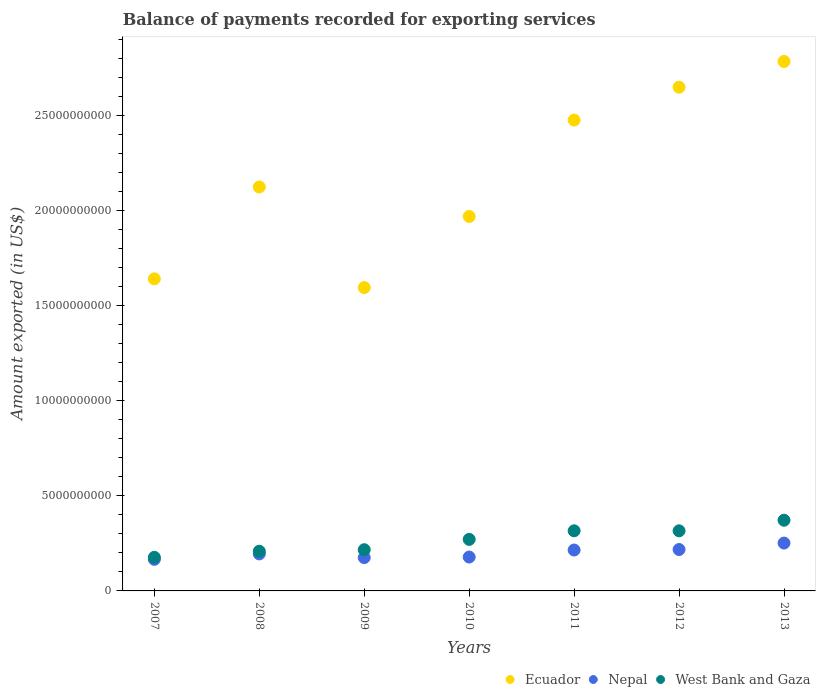Is the number of dotlines equal to the number of legend labels?
Ensure brevity in your answer.  Yes. What is the amount exported in Ecuador in 2011?
Give a very brief answer. 2.48e+1. Across all years, what is the maximum amount exported in Nepal?
Offer a very short reply. 2.52e+09. Across all years, what is the minimum amount exported in Nepal?
Give a very brief answer. 1.66e+09. In which year was the amount exported in Ecuador minimum?
Keep it short and to the point. 2009. What is the total amount exported in Ecuador in the graph?
Provide a short and direct response. 1.52e+11. What is the difference between the amount exported in Nepal in 2010 and that in 2013?
Offer a terse response. -7.35e+08. What is the difference between the amount exported in Ecuador in 2011 and the amount exported in Nepal in 2013?
Keep it short and to the point. 2.22e+1. What is the average amount exported in Nepal per year?
Your answer should be compact. 2.00e+09. In the year 2012, what is the difference between the amount exported in Ecuador and amount exported in Nepal?
Your response must be concise. 2.43e+1. In how many years, is the amount exported in West Bank and Gaza greater than 19000000000 US$?
Make the answer very short. 0. What is the ratio of the amount exported in Ecuador in 2009 to that in 2010?
Your answer should be compact. 0.81. What is the difference between the highest and the second highest amount exported in Ecuador?
Your answer should be very brief. 1.35e+09. What is the difference between the highest and the lowest amount exported in Nepal?
Keep it short and to the point. 8.55e+08. In how many years, is the amount exported in Ecuador greater than the average amount exported in Ecuador taken over all years?
Make the answer very short. 3. Does the amount exported in Nepal monotonically increase over the years?
Give a very brief answer. No. Is the amount exported in West Bank and Gaza strictly greater than the amount exported in Nepal over the years?
Your response must be concise. Yes. How many dotlines are there?
Provide a short and direct response. 3. How many years are there in the graph?
Keep it short and to the point. 7. What is the difference between two consecutive major ticks on the Y-axis?
Offer a very short reply. 5.00e+09. How many legend labels are there?
Provide a succinct answer. 3. What is the title of the graph?
Provide a short and direct response. Balance of payments recorded for exporting services. Does "United Kingdom" appear as one of the legend labels in the graph?
Provide a succinct answer. No. What is the label or title of the X-axis?
Provide a succinct answer. Years. What is the label or title of the Y-axis?
Provide a succinct answer. Amount exported (in US$). What is the Amount exported (in US$) in Ecuador in 2007?
Your answer should be compact. 1.64e+1. What is the Amount exported (in US$) in Nepal in 2007?
Your answer should be compact. 1.66e+09. What is the Amount exported (in US$) of West Bank and Gaza in 2007?
Keep it short and to the point. 1.77e+09. What is the Amount exported (in US$) of Ecuador in 2008?
Your response must be concise. 2.12e+1. What is the Amount exported (in US$) of Nepal in 2008?
Your answer should be very brief. 1.95e+09. What is the Amount exported (in US$) of West Bank and Gaza in 2008?
Your answer should be very brief. 2.09e+09. What is the Amount exported (in US$) in Ecuador in 2009?
Make the answer very short. 1.59e+1. What is the Amount exported (in US$) in Nepal in 2009?
Offer a very short reply. 1.75e+09. What is the Amount exported (in US$) in West Bank and Gaza in 2009?
Provide a short and direct response. 2.17e+09. What is the Amount exported (in US$) of Ecuador in 2010?
Provide a short and direct response. 1.97e+1. What is the Amount exported (in US$) of Nepal in 2010?
Give a very brief answer. 1.78e+09. What is the Amount exported (in US$) of West Bank and Gaza in 2010?
Make the answer very short. 2.71e+09. What is the Amount exported (in US$) of Ecuador in 2011?
Provide a succinct answer. 2.48e+1. What is the Amount exported (in US$) of Nepal in 2011?
Ensure brevity in your answer.  2.15e+09. What is the Amount exported (in US$) in West Bank and Gaza in 2011?
Ensure brevity in your answer.  3.16e+09. What is the Amount exported (in US$) in Ecuador in 2012?
Keep it short and to the point. 2.65e+1. What is the Amount exported (in US$) in Nepal in 2012?
Provide a short and direct response. 2.18e+09. What is the Amount exported (in US$) of West Bank and Gaza in 2012?
Offer a very short reply. 3.16e+09. What is the Amount exported (in US$) of Ecuador in 2013?
Keep it short and to the point. 2.78e+1. What is the Amount exported (in US$) in Nepal in 2013?
Give a very brief answer. 2.52e+09. What is the Amount exported (in US$) in West Bank and Gaza in 2013?
Your answer should be compact. 3.72e+09. Across all years, what is the maximum Amount exported (in US$) of Ecuador?
Keep it short and to the point. 2.78e+1. Across all years, what is the maximum Amount exported (in US$) of Nepal?
Provide a succinct answer. 2.52e+09. Across all years, what is the maximum Amount exported (in US$) in West Bank and Gaza?
Ensure brevity in your answer.  3.72e+09. Across all years, what is the minimum Amount exported (in US$) of Ecuador?
Ensure brevity in your answer.  1.59e+1. Across all years, what is the minimum Amount exported (in US$) in Nepal?
Provide a succinct answer. 1.66e+09. Across all years, what is the minimum Amount exported (in US$) of West Bank and Gaza?
Ensure brevity in your answer.  1.77e+09. What is the total Amount exported (in US$) of Ecuador in the graph?
Your response must be concise. 1.52e+11. What is the total Amount exported (in US$) in Nepal in the graph?
Provide a short and direct response. 1.40e+1. What is the total Amount exported (in US$) in West Bank and Gaza in the graph?
Make the answer very short. 1.88e+1. What is the difference between the Amount exported (in US$) in Ecuador in 2007 and that in 2008?
Provide a short and direct response. -4.83e+09. What is the difference between the Amount exported (in US$) in Nepal in 2007 and that in 2008?
Offer a terse response. -2.85e+08. What is the difference between the Amount exported (in US$) of West Bank and Gaza in 2007 and that in 2008?
Offer a very short reply. -3.21e+08. What is the difference between the Amount exported (in US$) in Ecuador in 2007 and that in 2009?
Provide a short and direct response. 4.60e+08. What is the difference between the Amount exported (in US$) in Nepal in 2007 and that in 2009?
Provide a short and direct response. -9.15e+07. What is the difference between the Amount exported (in US$) of West Bank and Gaza in 2007 and that in 2009?
Make the answer very short. -4.00e+08. What is the difference between the Amount exported (in US$) of Ecuador in 2007 and that in 2010?
Provide a succinct answer. -3.28e+09. What is the difference between the Amount exported (in US$) in Nepal in 2007 and that in 2010?
Make the answer very short. -1.21e+08. What is the difference between the Amount exported (in US$) in West Bank and Gaza in 2007 and that in 2010?
Your response must be concise. -9.44e+08. What is the difference between the Amount exported (in US$) in Ecuador in 2007 and that in 2011?
Your answer should be very brief. -8.35e+09. What is the difference between the Amount exported (in US$) in Nepal in 2007 and that in 2011?
Provide a short and direct response. -4.90e+08. What is the difference between the Amount exported (in US$) of West Bank and Gaza in 2007 and that in 2011?
Give a very brief answer. -1.39e+09. What is the difference between the Amount exported (in US$) in Ecuador in 2007 and that in 2012?
Give a very brief answer. -1.01e+1. What is the difference between the Amount exported (in US$) in Nepal in 2007 and that in 2012?
Offer a terse response. -5.16e+08. What is the difference between the Amount exported (in US$) in West Bank and Gaza in 2007 and that in 2012?
Your response must be concise. -1.39e+09. What is the difference between the Amount exported (in US$) of Ecuador in 2007 and that in 2013?
Keep it short and to the point. -1.14e+1. What is the difference between the Amount exported (in US$) in Nepal in 2007 and that in 2013?
Provide a short and direct response. -8.55e+08. What is the difference between the Amount exported (in US$) in West Bank and Gaza in 2007 and that in 2013?
Provide a short and direct response. -1.95e+09. What is the difference between the Amount exported (in US$) in Ecuador in 2008 and that in 2009?
Your response must be concise. 5.29e+09. What is the difference between the Amount exported (in US$) in Nepal in 2008 and that in 2009?
Your answer should be compact. 1.94e+08. What is the difference between the Amount exported (in US$) of West Bank and Gaza in 2008 and that in 2009?
Provide a succinct answer. -7.94e+07. What is the difference between the Amount exported (in US$) in Ecuador in 2008 and that in 2010?
Your answer should be very brief. 1.55e+09. What is the difference between the Amount exported (in US$) of Nepal in 2008 and that in 2010?
Your answer should be compact. 1.65e+08. What is the difference between the Amount exported (in US$) of West Bank and Gaza in 2008 and that in 2010?
Your answer should be very brief. -6.23e+08. What is the difference between the Amount exported (in US$) in Ecuador in 2008 and that in 2011?
Provide a short and direct response. -3.52e+09. What is the difference between the Amount exported (in US$) of Nepal in 2008 and that in 2011?
Offer a terse response. -2.04e+08. What is the difference between the Amount exported (in US$) in West Bank and Gaza in 2008 and that in 2011?
Your answer should be very brief. -1.07e+09. What is the difference between the Amount exported (in US$) of Ecuador in 2008 and that in 2012?
Offer a very short reply. -5.25e+09. What is the difference between the Amount exported (in US$) in Nepal in 2008 and that in 2012?
Make the answer very short. -2.31e+08. What is the difference between the Amount exported (in US$) of West Bank and Gaza in 2008 and that in 2012?
Keep it short and to the point. -1.07e+09. What is the difference between the Amount exported (in US$) in Ecuador in 2008 and that in 2013?
Your response must be concise. -6.60e+09. What is the difference between the Amount exported (in US$) in Nepal in 2008 and that in 2013?
Offer a terse response. -5.70e+08. What is the difference between the Amount exported (in US$) of West Bank and Gaza in 2008 and that in 2013?
Your answer should be very brief. -1.63e+09. What is the difference between the Amount exported (in US$) of Ecuador in 2009 and that in 2010?
Keep it short and to the point. -3.74e+09. What is the difference between the Amount exported (in US$) in Nepal in 2009 and that in 2010?
Your response must be concise. -2.91e+07. What is the difference between the Amount exported (in US$) in West Bank and Gaza in 2009 and that in 2010?
Keep it short and to the point. -5.44e+08. What is the difference between the Amount exported (in US$) of Ecuador in 2009 and that in 2011?
Your response must be concise. -8.81e+09. What is the difference between the Amount exported (in US$) in Nepal in 2009 and that in 2011?
Your answer should be very brief. -3.98e+08. What is the difference between the Amount exported (in US$) in West Bank and Gaza in 2009 and that in 2011?
Your response must be concise. -9.94e+08. What is the difference between the Amount exported (in US$) of Ecuador in 2009 and that in 2012?
Your answer should be very brief. -1.05e+1. What is the difference between the Amount exported (in US$) of Nepal in 2009 and that in 2012?
Offer a very short reply. -4.25e+08. What is the difference between the Amount exported (in US$) in West Bank and Gaza in 2009 and that in 2012?
Make the answer very short. -9.93e+08. What is the difference between the Amount exported (in US$) in Ecuador in 2009 and that in 2013?
Your answer should be very brief. -1.19e+1. What is the difference between the Amount exported (in US$) in Nepal in 2009 and that in 2013?
Make the answer very short. -7.64e+08. What is the difference between the Amount exported (in US$) of West Bank and Gaza in 2009 and that in 2013?
Your answer should be compact. -1.55e+09. What is the difference between the Amount exported (in US$) in Ecuador in 2010 and that in 2011?
Your response must be concise. -5.07e+09. What is the difference between the Amount exported (in US$) of Nepal in 2010 and that in 2011?
Make the answer very short. -3.69e+08. What is the difference between the Amount exported (in US$) in West Bank and Gaza in 2010 and that in 2011?
Keep it short and to the point. -4.51e+08. What is the difference between the Amount exported (in US$) in Ecuador in 2010 and that in 2012?
Ensure brevity in your answer.  -6.79e+09. What is the difference between the Amount exported (in US$) of Nepal in 2010 and that in 2012?
Keep it short and to the point. -3.96e+08. What is the difference between the Amount exported (in US$) of West Bank and Gaza in 2010 and that in 2012?
Ensure brevity in your answer.  -4.50e+08. What is the difference between the Amount exported (in US$) in Ecuador in 2010 and that in 2013?
Your answer should be very brief. -8.15e+09. What is the difference between the Amount exported (in US$) in Nepal in 2010 and that in 2013?
Your answer should be very brief. -7.35e+08. What is the difference between the Amount exported (in US$) of West Bank and Gaza in 2010 and that in 2013?
Make the answer very short. -1.01e+09. What is the difference between the Amount exported (in US$) in Ecuador in 2011 and that in 2012?
Keep it short and to the point. -1.73e+09. What is the difference between the Amount exported (in US$) in Nepal in 2011 and that in 2012?
Your response must be concise. -2.65e+07. What is the difference between the Amount exported (in US$) in West Bank and Gaza in 2011 and that in 2012?
Provide a short and direct response. 9.34e+05. What is the difference between the Amount exported (in US$) of Ecuador in 2011 and that in 2013?
Your answer should be compact. -3.08e+09. What is the difference between the Amount exported (in US$) in Nepal in 2011 and that in 2013?
Your answer should be very brief. -3.66e+08. What is the difference between the Amount exported (in US$) of West Bank and Gaza in 2011 and that in 2013?
Make the answer very short. -5.55e+08. What is the difference between the Amount exported (in US$) of Ecuador in 2012 and that in 2013?
Provide a short and direct response. -1.35e+09. What is the difference between the Amount exported (in US$) in Nepal in 2012 and that in 2013?
Make the answer very short. -3.39e+08. What is the difference between the Amount exported (in US$) of West Bank and Gaza in 2012 and that in 2013?
Give a very brief answer. -5.56e+08. What is the difference between the Amount exported (in US$) in Ecuador in 2007 and the Amount exported (in US$) in Nepal in 2008?
Your response must be concise. 1.45e+1. What is the difference between the Amount exported (in US$) in Ecuador in 2007 and the Amount exported (in US$) in West Bank and Gaza in 2008?
Your answer should be compact. 1.43e+1. What is the difference between the Amount exported (in US$) of Nepal in 2007 and the Amount exported (in US$) of West Bank and Gaza in 2008?
Your answer should be compact. -4.27e+08. What is the difference between the Amount exported (in US$) in Ecuador in 2007 and the Amount exported (in US$) in Nepal in 2009?
Make the answer very short. 1.47e+1. What is the difference between the Amount exported (in US$) of Ecuador in 2007 and the Amount exported (in US$) of West Bank and Gaza in 2009?
Ensure brevity in your answer.  1.42e+1. What is the difference between the Amount exported (in US$) in Nepal in 2007 and the Amount exported (in US$) in West Bank and Gaza in 2009?
Your answer should be very brief. -5.06e+08. What is the difference between the Amount exported (in US$) in Ecuador in 2007 and the Amount exported (in US$) in Nepal in 2010?
Give a very brief answer. 1.46e+1. What is the difference between the Amount exported (in US$) of Ecuador in 2007 and the Amount exported (in US$) of West Bank and Gaza in 2010?
Your response must be concise. 1.37e+1. What is the difference between the Amount exported (in US$) in Nepal in 2007 and the Amount exported (in US$) in West Bank and Gaza in 2010?
Provide a succinct answer. -1.05e+09. What is the difference between the Amount exported (in US$) of Ecuador in 2007 and the Amount exported (in US$) of Nepal in 2011?
Provide a succinct answer. 1.43e+1. What is the difference between the Amount exported (in US$) in Ecuador in 2007 and the Amount exported (in US$) in West Bank and Gaza in 2011?
Keep it short and to the point. 1.32e+1. What is the difference between the Amount exported (in US$) in Nepal in 2007 and the Amount exported (in US$) in West Bank and Gaza in 2011?
Offer a terse response. -1.50e+09. What is the difference between the Amount exported (in US$) in Ecuador in 2007 and the Amount exported (in US$) in Nepal in 2012?
Give a very brief answer. 1.42e+1. What is the difference between the Amount exported (in US$) of Ecuador in 2007 and the Amount exported (in US$) of West Bank and Gaza in 2012?
Offer a very short reply. 1.32e+1. What is the difference between the Amount exported (in US$) of Nepal in 2007 and the Amount exported (in US$) of West Bank and Gaza in 2012?
Keep it short and to the point. -1.50e+09. What is the difference between the Amount exported (in US$) in Ecuador in 2007 and the Amount exported (in US$) in Nepal in 2013?
Offer a very short reply. 1.39e+1. What is the difference between the Amount exported (in US$) of Ecuador in 2007 and the Amount exported (in US$) of West Bank and Gaza in 2013?
Your answer should be very brief. 1.27e+1. What is the difference between the Amount exported (in US$) of Nepal in 2007 and the Amount exported (in US$) of West Bank and Gaza in 2013?
Ensure brevity in your answer.  -2.06e+09. What is the difference between the Amount exported (in US$) in Ecuador in 2008 and the Amount exported (in US$) in Nepal in 2009?
Your answer should be compact. 1.95e+1. What is the difference between the Amount exported (in US$) in Ecuador in 2008 and the Amount exported (in US$) in West Bank and Gaza in 2009?
Your answer should be very brief. 1.91e+1. What is the difference between the Amount exported (in US$) of Nepal in 2008 and the Amount exported (in US$) of West Bank and Gaza in 2009?
Your answer should be very brief. -2.21e+08. What is the difference between the Amount exported (in US$) in Ecuador in 2008 and the Amount exported (in US$) in Nepal in 2010?
Your answer should be very brief. 1.95e+1. What is the difference between the Amount exported (in US$) of Ecuador in 2008 and the Amount exported (in US$) of West Bank and Gaza in 2010?
Make the answer very short. 1.85e+1. What is the difference between the Amount exported (in US$) of Nepal in 2008 and the Amount exported (in US$) of West Bank and Gaza in 2010?
Provide a succinct answer. -7.64e+08. What is the difference between the Amount exported (in US$) of Ecuador in 2008 and the Amount exported (in US$) of Nepal in 2011?
Ensure brevity in your answer.  1.91e+1. What is the difference between the Amount exported (in US$) in Ecuador in 2008 and the Amount exported (in US$) in West Bank and Gaza in 2011?
Ensure brevity in your answer.  1.81e+1. What is the difference between the Amount exported (in US$) in Nepal in 2008 and the Amount exported (in US$) in West Bank and Gaza in 2011?
Keep it short and to the point. -1.21e+09. What is the difference between the Amount exported (in US$) of Ecuador in 2008 and the Amount exported (in US$) of Nepal in 2012?
Provide a short and direct response. 1.91e+1. What is the difference between the Amount exported (in US$) in Ecuador in 2008 and the Amount exported (in US$) in West Bank and Gaza in 2012?
Offer a very short reply. 1.81e+1. What is the difference between the Amount exported (in US$) in Nepal in 2008 and the Amount exported (in US$) in West Bank and Gaza in 2012?
Offer a very short reply. -1.21e+09. What is the difference between the Amount exported (in US$) of Ecuador in 2008 and the Amount exported (in US$) of Nepal in 2013?
Make the answer very short. 1.87e+1. What is the difference between the Amount exported (in US$) of Ecuador in 2008 and the Amount exported (in US$) of West Bank and Gaza in 2013?
Your answer should be compact. 1.75e+1. What is the difference between the Amount exported (in US$) of Nepal in 2008 and the Amount exported (in US$) of West Bank and Gaza in 2013?
Make the answer very short. -1.77e+09. What is the difference between the Amount exported (in US$) in Ecuador in 2009 and the Amount exported (in US$) in Nepal in 2010?
Your response must be concise. 1.42e+1. What is the difference between the Amount exported (in US$) of Ecuador in 2009 and the Amount exported (in US$) of West Bank and Gaza in 2010?
Provide a succinct answer. 1.32e+1. What is the difference between the Amount exported (in US$) in Nepal in 2009 and the Amount exported (in US$) in West Bank and Gaza in 2010?
Keep it short and to the point. -9.58e+08. What is the difference between the Amount exported (in US$) of Ecuador in 2009 and the Amount exported (in US$) of Nepal in 2011?
Your response must be concise. 1.38e+1. What is the difference between the Amount exported (in US$) of Ecuador in 2009 and the Amount exported (in US$) of West Bank and Gaza in 2011?
Ensure brevity in your answer.  1.28e+1. What is the difference between the Amount exported (in US$) in Nepal in 2009 and the Amount exported (in US$) in West Bank and Gaza in 2011?
Make the answer very short. -1.41e+09. What is the difference between the Amount exported (in US$) in Ecuador in 2009 and the Amount exported (in US$) in Nepal in 2012?
Offer a terse response. 1.38e+1. What is the difference between the Amount exported (in US$) of Ecuador in 2009 and the Amount exported (in US$) of West Bank and Gaza in 2012?
Ensure brevity in your answer.  1.28e+1. What is the difference between the Amount exported (in US$) of Nepal in 2009 and the Amount exported (in US$) of West Bank and Gaza in 2012?
Provide a short and direct response. -1.41e+09. What is the difference between the Amount exported (in US$) of Ecuador in 2009 and the Amount exported (in US$) of Nepal in 2013?
Your response must be concise. 1.34e+1. What is the difference between the Amount exported (in US$) in Ecuador in 2009 and the Amount exported (in US$) in West Bank and Gaza in 2013?
Provide a short and direct response. 1.22e+1. What is the difference between the Amount exported (in US$) in Nepal in 2009 and the Amount exported (in US$) in West Bank and Gaza in 2013?
Your response must be concise. -1.96e+09. What is the difference between the Amount exported (in US$) in Ecuador in 2010 and the Amount exported (in US$) in Nepal in 2011?
Make the answer very short. 1.75e+1. What is the difference between the Amount exported (in US$) of Ecuador in 2010 and the Amount exported (in US$) of West Bank and Gaza in 2011?
Your answer should be compact. 1.65e+1. What is the difference between the Amount exported (in US$) of Nepal in 2010 and the Amount exported (in US$) of West Bank and Gaza in 2011?
Give a very brief answer. -1.38e+09. What is the difference between the Amount exported (in US$) in Ecuador in 2010 and the Amount exported (in US$) in Nepal in 2012?
Offer a very short reply. 1.75e+1. What is the difference between the Amount exported (in US$) of Ecuador in 2010 and the Amount exported (in US$) of West Bank and Gaza in 2012?
Offer a terse response. 1.65e+1. What is the difference between the Amount exported (in US$) in Nepal in 2010 and the Amount exported (in US$) in West Bank and Gaza in 2012?
Keep it short and to the point. -1.38e+09. What is the difference between the Amount exported (in US$) in Ecuador in 2010 and the Amount exported (in US$) in Nepal in 2013?
Provide a succinct answer. 1.72e+1. What is the difference between the Amount exported (in US$) in Ecuador in 2010 and the Amount exported (in US$) in West Bank and Gaza in 2013?
Make the answer very short. 1.60e+1. What is the difference between the Amount exported (in US$) of Nepal in 2010 and the Amount exported (in US$) of West Bank and Gaza in 2013?
Provide a succinct answer. -1.94e+09. What is the difference between the Amount exported (in US$) in Ecuador in 2011 and the Amount exported (in US$) in Nepal in 2012?
Your answer should be compact. 2.26e+1. What is the difference between the Amount exported (in US$) in Ecuador in 2011 and the Amount exported (in US$) in West Bank and Gaza in 2012?
Offer a very short reply. 2.16e+1. What is the difference between the Amount exported (in US$) of Nepal in 2011 and the Amount exported (in US$) of West Bank and Gaza in 2012?
Make the answer very short. -1.01e+09. What is the difference between the Amount exported (in US$) of Ecuador in 2011 and the Amount exported (in US$) of Nepal in 2013?
Keep it short and to the point. 2.22e+1. What is the difference between the Amount exported (in US$) of Ecuador in 2011 and the Amount exported (in US$) of West Bank and Gaza in 2013?
Provide a succinct answer. 2.10e+1. What is the difference between the Amount exported (in US$) of Nepal in 2011 and the Amount exported (in US$) of West Bank and Gaza in 2013?
Your answer should be compact. -1.57e+09. What is the difference between the Amount exported (in US$) of Ecuador in 2012 and the Amount exported (in US$) of Nepal in 2013?
Make the answer very short. 2.40e+1. What is the difference between the Amount exported (in US$) of Ecuador in 2012 and the Amount exported (in US$) of West Bank and Gaza in 2013?
Your answer should be compact. 2.28e+1. What is the difference between the Amount exported (in US$) in Nepal in 2012 and the Amount exported (in US$) in West Bank and Gaza in 2013?
Keep it short and to the point. -1.54e+09. What is the average Amount exported (in US$) of Ecuador per year?
Your answer should be compact. 2.18e+1. What is the average Amount exported (in US$) of Nepal per year?
Offer a very short reply. 2.00e+09. What is the average Amount exported (in US$) in West Bank and Gaza per year?
Your answer should be very brief. 2.68e+09. In the year 2007, what is the difference between the Amount exported (in US$) in Ecuador and Amount exported (in US$) in Nepal?
Provide a succinct answer. 1.47e+1. In the year 2007, what is the difference between the Amount exported (in US$) of Ecuador and Amount exported (in US$) of West Bank and Gaza?
Keep it short and to the point. 1.46e+1. In the year 2007, what is the difference between the Amount exported (in US$) in Nepal and Amount exported (in US$) in West Bank and Gaza?
Provide a succinct answer. -1.06e+08. In the year 2008, what is the difference between the Amount exported (in US$) in Ecuador and Amount exported (in US$) in Nepal?
Provide a succinct answer. 1.93e+1. In the year 2008, what is the difference between the Amount exported (in US$) in Ecuador and Amount exported (in US$) in West Bank and Gaza?
Your answer should be compact. 1.91e+1. In the year 2008, what is the difference between the Amount exported (in US$) in Nepal and Amount exported (in US$) in West Bank and Gaza?
Keep it short and to the point. -1.41e+08. In the year 2009, what is the difference between the Amount exported (in US$) of Ecuador and Amount exported (in US$) of Nepal?
Your answer should be very brief. 1.42e+1. In the year 2009, what is the difference between the Amount exported (in US$) of Ecuador and Amount exported (in US$) of West Bank and Gaza?
Provide a short and direct response. 1.38e+1. In the year 2009, what is the difference between the Amount exported (in US$) in Nepal and Amount exported (in US$) in West Bank and Gaza?
Provide a short and direct response. -4.14e+08. In the year 2010, what is the difference between the Amount exported (in US$) of Ecuador and Amount exported (in US$) of Nepal?
Your answer should be very brief. 1.79e+1. In the year 2010, what is the difference between the Amount exported (in US$) in Ecuador and Amount exported (in US$) in West Bank and Gaza?
Provide a succinct answer. 1.70e+1. In the year 2010, what is the difference between the Amount exported (in US$) of Nepal and Amount exported (in US$) of West Bank and Gaza?
Your response must be concise. -9.29e+08. In the year 2011, what is the difference between the Amount exported (in US$) in Ecuador and Amount exported (in US$) in Nepal?
Provide a short and direct response. 2.26e+1. In the year 2011, what is the difference between the Amount exported (in US$) of Ecuador and Amount exported (in US$) of West Bank and Gaza?
Make the answer very short. 2.16e+1. In the year 2011, what is the difference between the Amount exported (in US$) in Nepal and Amount exported (in US$) in West Bank and Gaza?
Offer a terse response. -1.01e+09. In the year 2012, what is the difference between the Amount exported (in US$) in Ecuador and Amount exported (in US$) in Nepal?
Ensure brevity in your answer.  2.43e+1. In the year 2012, what is the difference between the Amount exported (in US$) of Ecuador and Amount exported (in US$) of West Bank and Gaza?
Your answer should be compact. 2.33e+1. In the year 2012, what is the difference between the Amount exported (in US$) in Nepal and Amount exported (in US$) in West Bank and Gaza?
Keep it short and to the point. -9.83e+08. In the year 2013, what is the difference between the Amount exported (in US$) of Ecuador and Amount exported (in US$) of Nepal?
Offer a terse response. 2.53e+1. In the year 2013, what is the difference between the Amount exported (in US$) in Ecuador and Amount exported (in US$) in West Bank and Gaza?
Your response must be concise. 2.41e+1. In the year 2013, what is the difference between the Amount exported (in US$) of Nepal and Amount exported (in US$) of West Bank and Gaza?
Make the answer very short. -1.20e+09. What is the ratio of the Amount exported (in US$) in Ecuador in 2007 to that in 2008?
Keep it short and to the point. 0.77. What is the ratio of the Amount exported (in US$) of Nepal in 2007 to that in 2008?
Your response must be concise. 0.85. What is the ratio of the Amount exported (in US$) of West Bank and Gaza in 2007 to that in 2008?
Your response must be concise. 0.85. What is the ratio of the Amount exported (in US$) in Ecuador in 2007 to that in 2009?
Your answer should be compact. 1.03. What is the ratio of the Amount exported (in US$) of Nepal in 2007 to that in 2009?
Keep it short and to the point. 0.95. What is the ratio of the Amount exported (in US$) in West Bank and Gaza in 2007 to that in 2009?
Your answer should be compact. 0.82. What is the ratio of the Amount exported (in US$) in Ecuador in 2007 to that in 2010?
Your answer should be very brief. 0.83. What is the ratio of the Amount exported (in US$) in Nepal in 2007 to that in 2010?
Offer a terse response. 0.93. What is the ratio of the Amount exported (in US$) of West Bank and Gaza in 2007 to that in 2010?
Offer a very short reply. 0.65. What is the ratio of the Amount exported (in US$) of Ecuador in 2007 to that in 2011?
Your answer should be compact. 0.66. What is the ratio of the Amount exported (in US$) of Nepal in 2007 to that in 2011?
Offer a very short reply. 0.77. What is the ratio of the Amount exported (in US$) in West Bank and Gaza in 2007 to that in 2011?
Keep it short and to the point. 0.56. What is the ratio of the Amount exported (in US$) in Ecuador in 2007 to that in 2012?
Your answer should be compact. 0.62. What is the ratio of the Amount exported (in US$) of Nepal in 2007 to that in 2012?
Ensure brevity in your answer.  0.76. What is the ratio of the Amount exported (in US$) of West Bank and Gaza in 2007 to that in 2012?
Provide a succinct answer. 0.56. What is the ratio of the Amount exported (in US$) in Ecuador in 2007 to that in 2013?
Offer a very short reply. 0.59. What is the ratio of the Amount exported (in US$) in Nepal in 2007 to that in 2013?
Keep it short and to the point. 0.66. What is the ratio of the Amount exported (in US$) in West Bank and Gaza in 2007 to that in 2013?
Give a very brief answer. 0.48. What is the ratio of the Amount exported (in US$) in Ecuador in 2008 to that in 2009?
Offer a terse response. 1.33. What is the ratio of the Amount exported (in US$) of Nepal in 2008 to that in 2009?
Your answer should be compact. 1.11. What is the ratio of the Amount exported (in US$) of West Bank and Gaza in 2008 to that in 2009?
Ensure brevity in your answer.  0.96. What is the ratio of the Amount exported (in US$) of Ecuador in 2008 to that in 2010?
Offer a very short reply. 1.08. What is the ratio of the Amount exported (in US$) in Nepal in 2008 to that in 2010?
Your answer should be compact. 1.09. What is the ratio of the Amount exported (in US$) of West Bank and Gaza in 2008 to that in 2010?
Keep it short and to the point. 0.77. What is the ratio of the Amount exported (in US$) in Ecuador in 2008 to that in 2011?
Your answer should be compact. 0.86. What is the ratio of the Amount exported (in US$) in Nepal in 2008 to that in 2011?
Provide a succinct answer. 0.91. What is the ratio of the Amount exported (in US$) in West Bank and Gaza in 2008 to that in 2011?
Your answer should be very brief. 0.66. What is the ratio of the Amount exported (in US$) of Ecuador in 2008 to that in 2012?
Make the answer very short. 0.8. What is the ratio of the Amount exported (in US$) in Nepal in 2008 to that in 2012?
Keep it short and to the point. 0.89. What is the ratio of the Amount exported (in US$) in West Bank and Gaza in 2008 to that in 2012?
Provide a short and direct response. 0.66. What is the ratio of the Amount exported (in US$) of Ecuador in 2008 to that in 2013?
Make the answer very short. 0.76. What is the ratio of the Amount exported (in US$) of Nepal in 2008 to that in 2013?
Offer a very short reply. 0.77. What is the ratio of the Amount exported (in US$) of West Bank and Gaza in 2008 to that in 2013?
Make the answer very short. 0.56. What is the ratio of the Amount exported (in US$) in Ecuador in 2009 to that in 2010?
Give a very brief answer. 0.81. What is the ratio of the Amount exported (in US$) of Nepal in 2009 to that in 2010?
Make the answer very short. 0.98. What is the ratio of the Amount exported (in US$) of West Bank and Gaza in 2009 to that in 2010?
Your response must be concise. 0.8. What is the ratio of the Amount exported (in US$) in Ecuador in 2009 to that in 2011?
Ensure brevity in your answer.  0.64. What is the ratio of the Amount exported (in US$) in Nepal in 2009 to that in 2011?
Ensure brevity in your answer.  0.81. What is the ratio of the Amount exported (in US$) of West Bank and Gaza in 2009 to that in 2011?
Ensure brevity in your answer.  0.69. What is the ratio of the Amount exported (in US$) of Ecuador in 2009 to that in 2012?
Provide a short and direct response. 0.6. What is the ratio of the Amount exported (in US$) in Nepal in 2009 to that in 2012?
Your answer should be very brief. 0.8. What is the ratio of the Amount exported (in US$) of West Bank and Gaza in 2009 to that in 2012?
Provide a succinct answer. 0.69. What is the ratio of the Amount exported (in US$) of Ecuador in 2009 to that in 2013?
Give a very brief answer. 0.57. What is the ratio of the Amount exported (in US$) of Nepal in 2009 to that in 2013?
Give a very brief answer. 0.7. What is the ratio of the Amount exported (in US$) of West Bank and Gaza in 2009 to that in 2013?
Ensure brevity in your answer.  0.58. What is the ratio of the Amount exported (in US$) of Ecuador in 2010 to that in 2011?
Offer a terse response. 0.8. What is the ratio of the Amount exported (in US$) in Nepal in 2010 to that in 2011?
Your answer should be compact. 0.83. What is the ratio of the Amount exported (in US$) of West Bank and Gaza in 2010 to that in 2011?
Make the answer very short. 0.86. What is the ratio of the Amount exported (in US$) in Ecuador in 2010 to that in 2012?
Keep it short and to the point. 0.74. What is the ratio of the Amount exported (in US$) of Nepal in 2010 to that in 2012?
Provide a succinct answer. 0.82. What is the ratio of the Amount exported (in US$) of West Bank and Gaza in 2010 to that in 2012?
Keep it short and to the point. 0.86. What is the ratio of the Amount exported (in US$) of Ecuador in 2010 to that in 2013?
Your answer should be compact. 0.71. What is the ratio of the Amount exported (in US$) in Nepal in 2010 to that in 2013?
Offer a very short reply. 0.71. What is the ratio of the Amount exported (in US$) in West Bank and Gaza in 2010 to that in 2013?
Provide a short and direct response. 0.73. What is the ratio of the Amount exported (in US$) in Ecuador in 2011 to that in 2012?
Make the answer very short. 0.93. What is the ratio of the Amount exported (in US$) of Nepal in 2011 to that in 2012?
Your answer should be compact. 0.99. What is the ratio of the Amount exported (in US$) in West Bank and Gaza in 2011 to that in 2012?
Your answer should be very brief. 1. What is the ratio of the Amount exported (in US$) in Ecuador in 2011 to that in 2013?
Provide a short and direct response. 0.89. What is the ratio of the Amount exported (in US$) in Nepal in 2011 to that in 2013?
Your answer should be compact. 0.85. What is the ratio of the Amount exported (in US$) in West Bank and Gaza in 2011 to that in 2013?
Your answer should be very brief. 0.85. What is the ratio of the Amount exported (in US$) of Ecuador in 2012 to that in 2013?
Your answer should be compact. 0.95. What is the ratio of the Amount exported (in US$) in Nepal in 2012 to that in 2013?
Provide a short and direct response. 0.87. What is the ratio of the Amount exported (in US$) in West Bank and Gaza in 2012 to that in 2013?
Ensure brevity in your answer.  0.85. What is the difference between the highest and the second highest Amount exported (in US$) in Ecuador?
Offer a very short reply. 1.35e+09. What is the difference between the highest and the second highest Amount exported (in US$) in Nepal?
Ensure brevity in your answer.  3.39e+08. What is the difference between the highest and the second highest Amount exported (in US$) in West Bank and Gaza?
Keep it short and to the point. 5.55e+08. What is the difference between the highest and the lowest Amount exported (in US$) of Ecuador?
Offer a very short reply. 1.19e+1. What is the difference between the highest and the lowest Amount exported (in US$) of Nepal?
Offer a terse response. 8.55e+08. What is the difference between the highest and the lowest Amount exported (in US$) of West Bank and Gaza?
Your answer should be compact. 1.95e+09. 